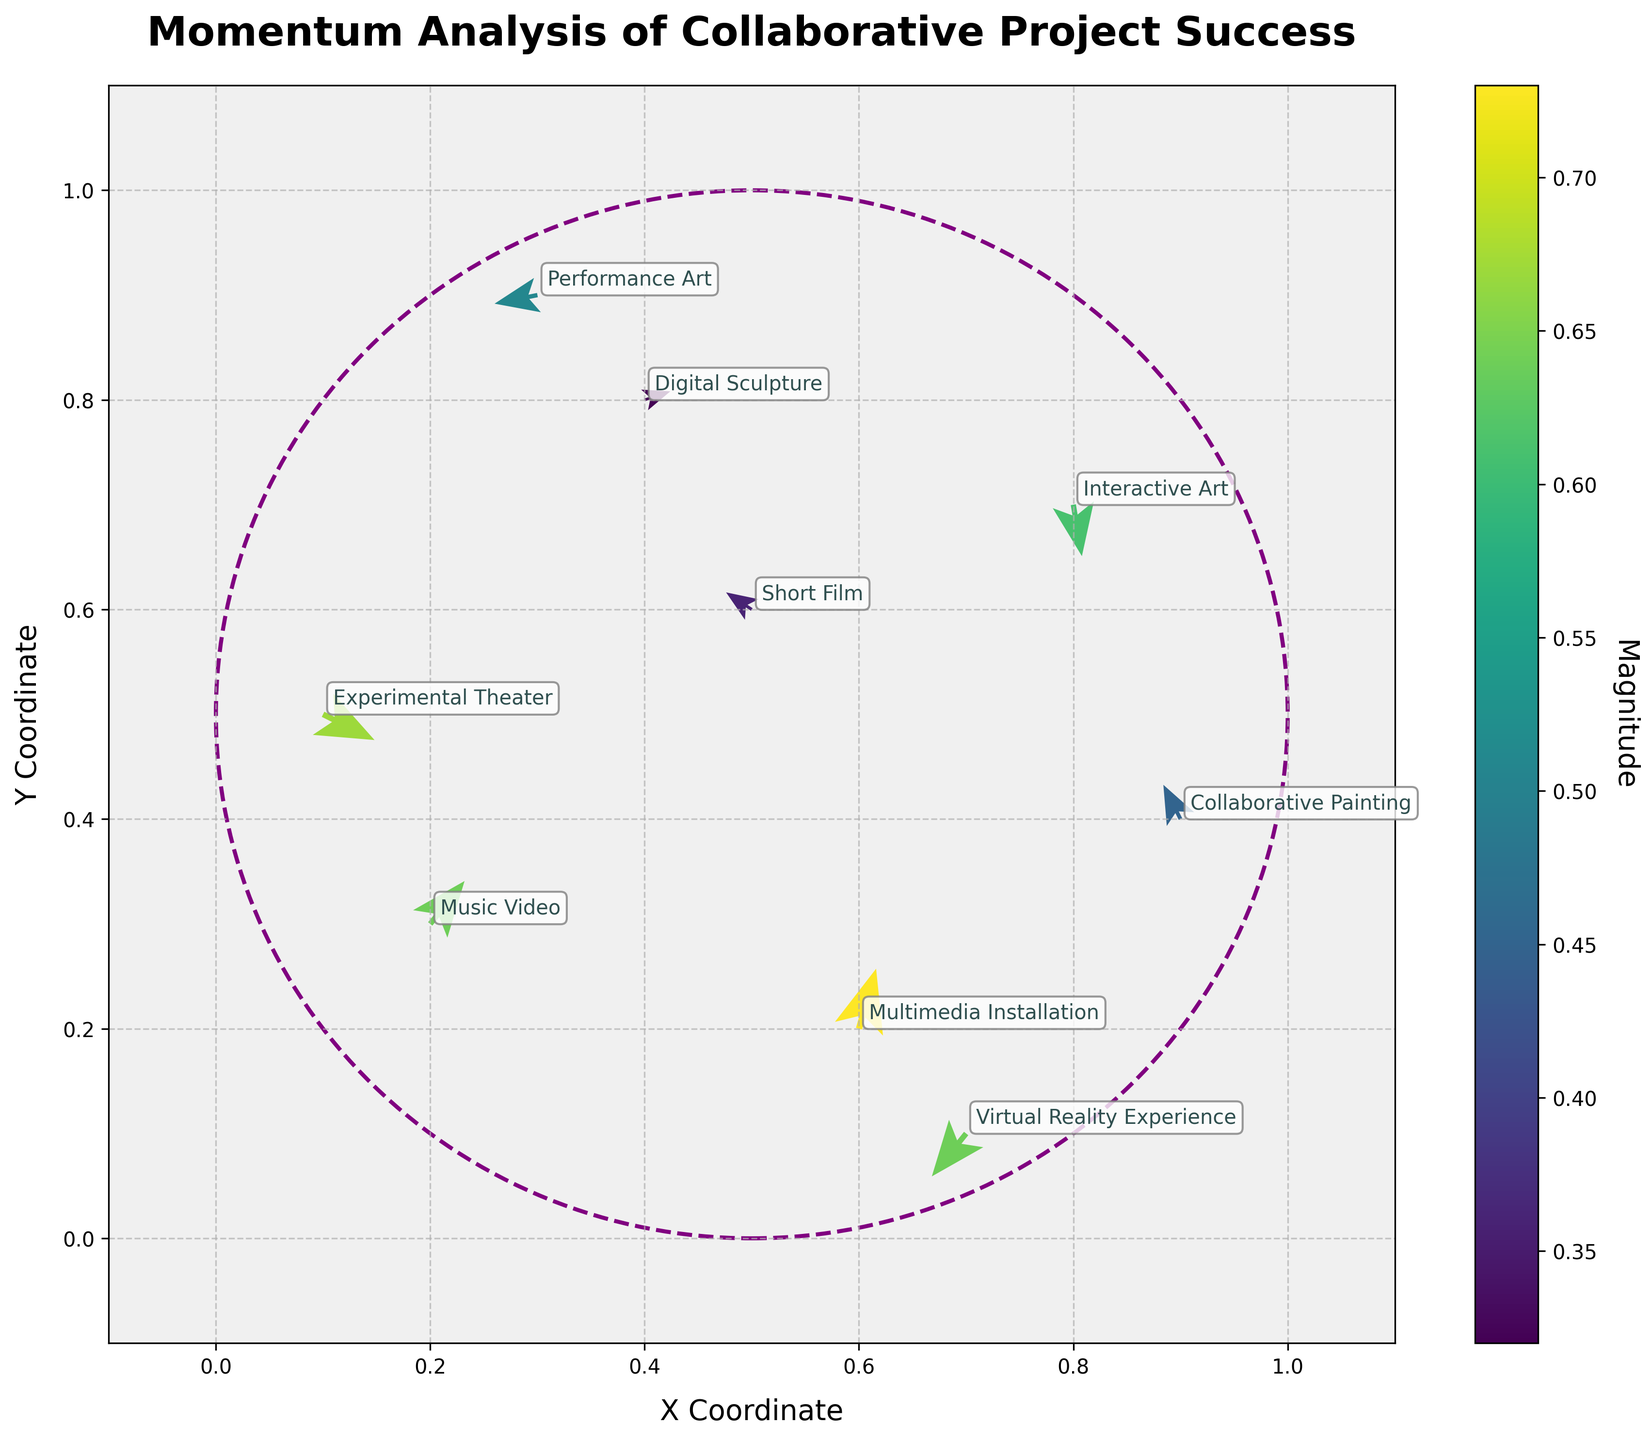What is the title of the plot? The title is bolded and located at the top of the plot. Observing it, we see that it reads "Momentum Analysis of Collaborative Project Success".
Answer: Momentum Analysis of Collaborative Project Success What are the labels of the X and Y axes? The labels are found on the horizontal (X) and vertical (Y) axes. The X axis is labeled "X Coordinate," and the Y axis is labeled "Y Coordinate."
Answer: X Coordinate and Y Coordinate How many data points are visualized in this plot? Each arrow represents a data point. Counting them, we find there are 9 arrows.
Answer: 9 Which project type has the highest magnitude of momentum? Magnitudes are represented by the color intensity in the plot. The project with the highest intensity (most vibrant color) is "Multimedia Installation" with a magnitude of 0.73.
Answer: Multimedia Installation Which two project types have negative U components? Observing the direction of the arrows, we identify that "Short Film" and "Performance Art" have negative U components as their arrows point leftward.
Answer: Short Film and Performance Art What is the average magnitude of the "Music Video" and "Collaborative Painting" projects? The magnitudes for "Music Video" and "Collaborative Painting" are 0.64 and 0.45, respectively. Averaging them: (0.64 + 0.45) / 2 = 0.545
Answer: 0.545 Compare the directions of the arrows for "Interactive Art" and "Virtual Reality Experience". Which one points downward? Observing the directions, the arrow for "Interactive Art" points downward (negative Y component), while "Virtual Reality Experience" points downward too. Therefore, both can be considered accurate.
Answer: Both "Interactive Art" and "Virtual Reality Experience" What is unique about the boundary of the plot? The boundary is identified by observing the circular dashed line encompassing the central area of the plot.
Answer: It has a circular boundary Which project's arrow is closest to the origin (0,0)? The proximity to the origin is evaluated by checking the coordinates close to (0,0). "Experimental Theater" at (0.1, 0.5) is the closest to the origin.
Answer: Experimental Theater 